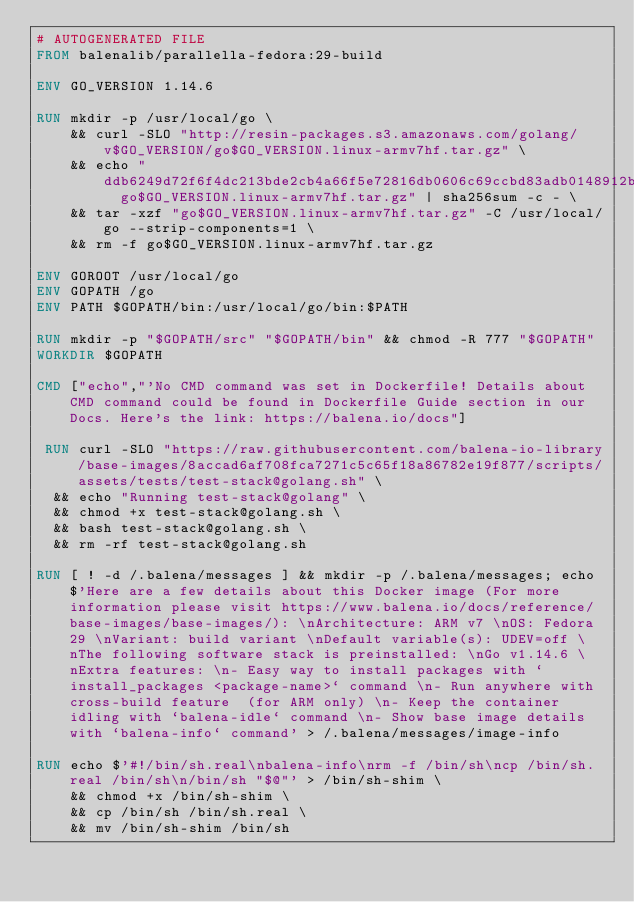<code> <loc_0><loc_0><loc_500><loc_500><_Dockerfile_># AUTOGENERATED FILE
FROM balenalib/parallella-fedora:29-build

ENV GO_VERSION 1.14.6

RUN mkdir -p /usr/local/go \
	&& curl -SLO "http://resin-packages.s3.amazonaws.com/golang/v$GO_VERSION/go$GO_VERSION.linux-armv7hf.tar.gz" \
	&& echo "ddb6249d72f6f4dc213bde2cb4a66f5e72816db0606c69ccbd83adb0148912b8  go$GO_VERSION.linux-armv7hf.tar.gz" | sha256sum -c - \
	&& tar -xzf "go$GO_VERSION.linux-armv7hf.tar.gz" -C /usr/local/go --strip-components=1 \
	&& rm -f go$GO_VERSION.linux-armv7hf.tar.gz

ENV GOROOT /usr/local/go
ENV GOPATH /go
ENV PATH $GOPATH/bin:/usr/local/go/bin:$PATH

RUN mkdir -p "$GOPATH/src" "$GOPATH/bin" && chmod -R 777 "$GOPATH"
WORKDIR $GOPATH

CMD ["echo","'No CMD command was set in Dockerfile! Details about CMD command could be found in Dockerfile Guide section in our Docs. Here's the link: https://balena.io/docs"]

 RUN curl -SLO "https://raw.githubusercontent.com/balena-io-library/base-images/8accad6af708fca7271c5c65f18a86782e19f877/scripts/assets/tests/test-stack@golang.sh" \
  && echo "Running test-stack@golang" \
  && chmod +x test-stack@golang.sh \
  && bash test-stack@golang.sh \
  && rm -rf test-stack@golang.sh 

RUN [ ! -d /.balena/messages ] && mkdir -p /.balena/messages; echo $'Here are a few details about this Docker image (For more information please visit https://www.balena.io/docs/reference/base-images/base-images/): \nArchitecture: ARM v7 \nOS: Fedora 29 \nVariant: build variant \nDefault variable(s): UDEV=off \nThe following software stack is preinstalled: \nGo v1.14.6 \nExtra features: \n- Easy way to install packages with `install_packages <package-name>` command \n- Run anywhere with cross-build feature  (for ARM only) \n- Keep the container idling with `balena-idle` command \n- Show base image details with `balena-info` command' > /.balena/messages/image-info

RUN echo $'#!/bin/sh.real\nbalena-info\nrm -f /bin/sh\ncp /bin/sh.real /bin/sh\n/bin/sh "$@"' > /bin/sh-shim \
	&& chmod +x /bin/sh-shim \
	&& cp /bin/sh /bin/sh.real \
	&& mv /bin/sh-shim /bin/sh</code> 